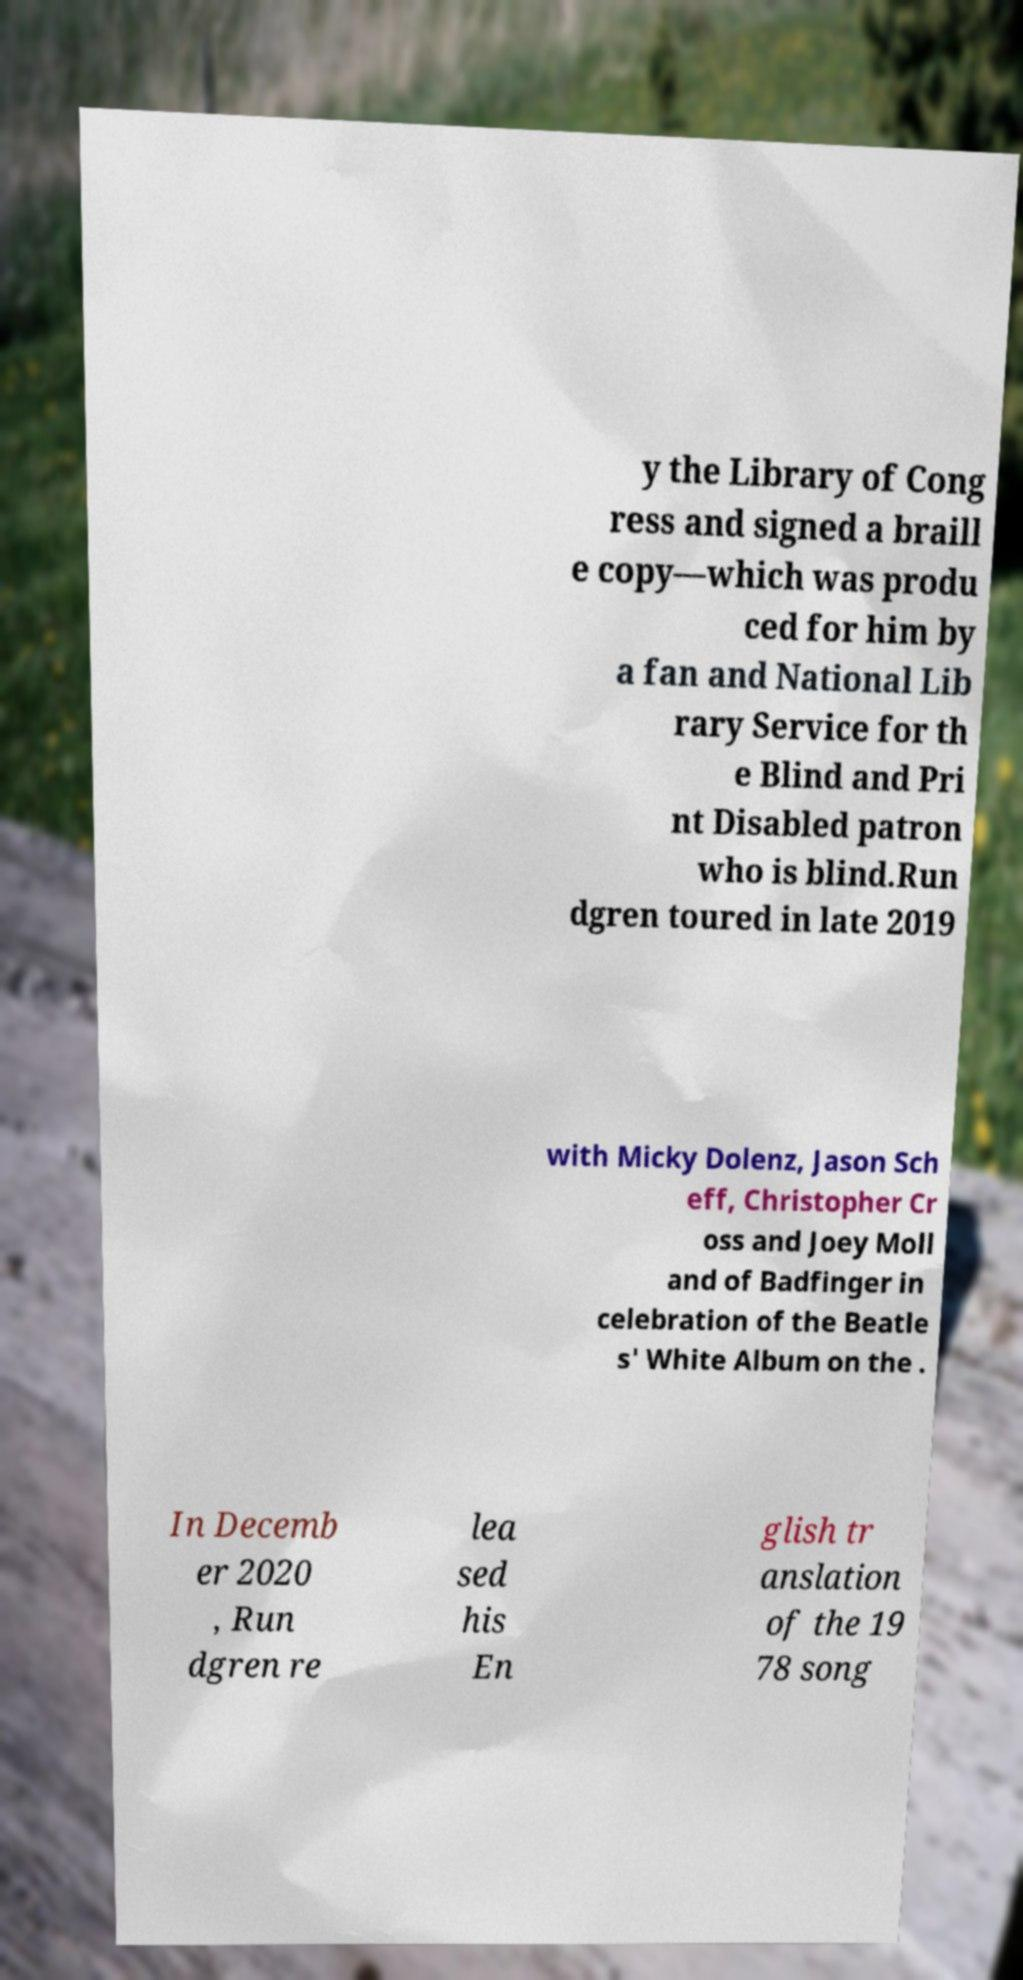Could you assist in decoding the text presented in this image and type it out clearly? y the Library of Cong ress and signed a braill e copy—which was produ ced for him by a fan and National Lib rary Service for th e Blind and Pri nt Disabled patron who is blind.Run dgren toured in late 2019 with Micky Dolenz, Jason Sch eff, Christopher Cr oss and Joey Moll and of Badfinger in celebration of the Beatle s' White Album on the . In Decemb er 2020 , Run dgren re lea sed his En glish tr anslation of the 19 78 song 